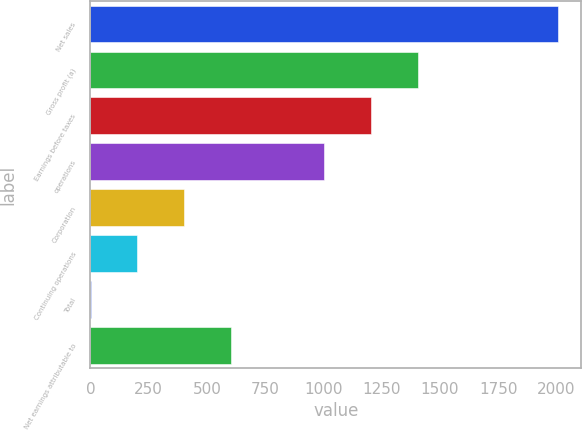<chart> <loc_0><loc_0><loc_500><loc_500><bar_chart><fcel>Net sales<fcel>Gross profit (a)<fcel>Earnings before taxes<fcel>operations<fcel>Corporation<fcel>Continuing operations<fcel>Total<fcel>Net earnings attributable to<nl><fcel>2007.5<fcel>1405.34<fcel>1204.63<fcel>1003.92<fcel>401.79<fcel>201.08<fcel>0.37<fcel>602.5<nl></chart> 